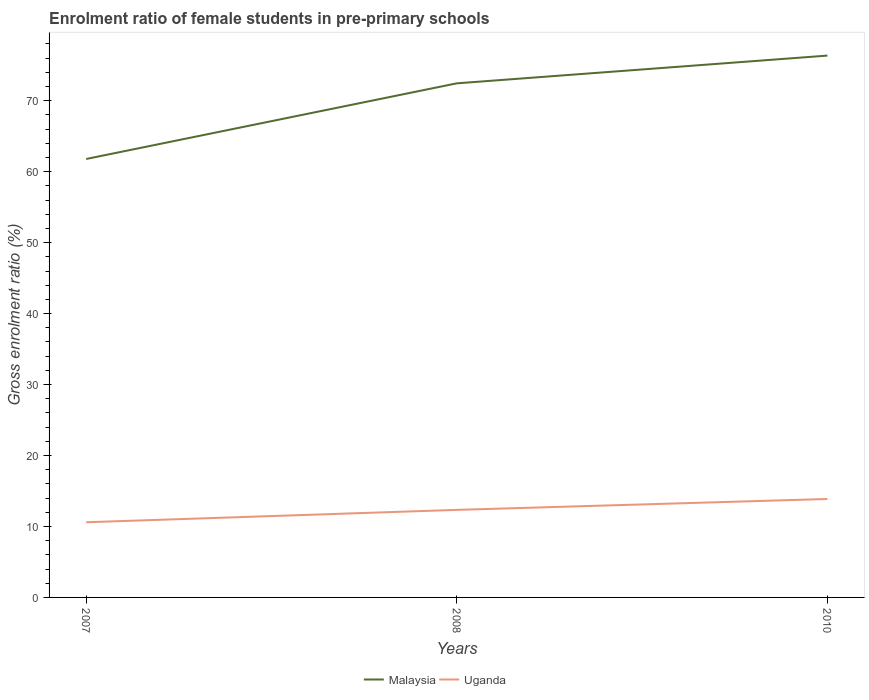Does the line corresponding to Uganda intersect with the line corresponding to Malaysia?
Your answer should be compact. No. Is the number of lines equal to the number of legend labels?
Offer a very short reply. Yes. Across all years, what is the maximum enrolment ratio of female students in pre-primary schools in Uganda?
Your answer should be compact. 10.59. What is the total enrolment ratio of female students in pre-primary schools in Uganda in the graph?
Provide a short and direct response. -1.54. What is the difference between the highest and the second highest enrolment ratio of female students in pre-primary schools in Uganda?
Provide a short and direct response. 3.28. How many lines are there?
Make the answer very short. 2. Does the graph contain grids?
Your answer should be very brief. No. How many legend labels are there?
Ensure brevity in your answer.  2. How are the legend labels stacked?
Provide a succinct answer. Horizontal. What is the title of the graph?
Keep it short and to the point. Enrolment ratio of female students in pre-primary schools. Does "Sub-Saharan Africa (developing only)" appear as one of the legend labels in the graph?
Make the answer very short. No. What is the label or title of the X-axis?
Ensure brevity in your answer.  Years. What is the Gross enrolment ratio (%) in Malaysia in 2007?
Provide a succinct answer. 61.79. What is the Gross enrolment ratio (%) of Uganda in 2007?
Make the answer very short. 10.59. What is the Gross enrolment ratio (%) in Malaysia in 2008?
Give a very brief answer. 72.45. What is the Gross enrolment ratio (%) in Uganda in 2008?
Provide a succinct answer. 12.34. What is the Gross enrolment ratio (%) in Malaysia in 2010?
Your answer should be compact. 76.36. What is the Gross enrolment ratio (%) of Uganda in 2010?
Provide a short and direct response. 13.87. Across all years, what is the maximum Gross enrolment ratio (%) in Malaysia?
Offer a very short reply. 76.36. Across all years, what is the maximum Gross enrolment ratio (%) in Uganda?
Ensure brevity in your answer.  13.87. Across all years, what is the minimum Gross enrolment ratio (%) in Malaysia?
Provide a short and direct response. 61.79. Across all years, what is the minimum Gross enrolment ratio (%) in Uganda?
Your answer should be compact. 10.59. What is the total Gross enrolment ratio (%) in Malaysia in the graph?
Provide a short and direct response. 210.6. What is the total Gross enrolment ratio (%) of Uganda in the graph?
Offer a terse response. 36.81. What is the difference between the Gross enrolment ratio (%) in Malaysia in 2007 and that in 2008?
Ensure brevity in your answer.  -10.66. What is the difference between the Gross enrolment ratio (%) of Uganda in 2007 and that in 2008?
Your answer should be compact. -1.74. What is the difference between the Gross enrolment ratio (%) of Malaysia in 2007 and that in 2010?
Ensure brevity in your answer.  -14.57. What is the difference between the Gross enrolment ratio (%) in Uganda in 2007 and that in 2010?
Your response must be concise. -3.28. What is the difference between the Gross enrolment ratio (%) of Malaysia in 2008 and that in 2010?
Your answer should be compact. -3.91. What is the difference between the Gross enrolment ratio (%) in Uganda in 2008 and that in 2010?
Provide a short and direct response. -1.54. What is the difference between the Gross enrolment ratio (%) of Malaysia in 2007 and the Gross enrolment ratio (%) of Uganda in 2008?
Give a very brief answer. 49.45. What is the difference between the Gross enrolment ratio (%) of Malaysia in 2007 and the Gross enrolment ratio (%) of Uganda in 2010?
Give a very brief answer. 47.92. What is the difference between the Gross enrolment ratio (%) in Malaysia in 2008 and the Gross enrolment ratio (%) in Uganda in 2010?
Provide a short and direct response. 58.58. What is the average Gross enrolment ratio (%) in Malaysia per year?
Ensure brevity in your answer.  70.2. What is the average Gross enrolment ratio (%) in Uganda per year?
Your response must be concise. 12.27. In the year 2007, what is the difference between the Gross enrolment ratio (%) in Malaysia and Gross enrolment ratio (%) in Uganda?
Keep it short and to the point. 51.2. In the year 2008, what is the difference between the Gross enrolment ratio (%) in Malaysia and Gross enrolment ratio (%) in Uganda?
Provide a succinct answer. 60.11. In the year 2010, what is the difference between the Gross enrolment ratio (%) in Malaysia and Gross enrolment ratio (%) in Uganda?
Give a very brief answer. 62.49. What is the ratio of the Gross enrolment ratio (%) in Malaysia in 2007 to that in 2008?
Your response must be concise. 0.85. What is the ratio of the Gross enrolment ratio (%) in Uganda in 2007 to that in 2008?
Offer a terse response. 0.86. What is the ratio of the Gross enrolment ratio (%) in Malaysia in 2007 to that in 2010?
Offer a terse response. 0.81. What is the ratio of the Gross enrolment ratio (%) of Uganda in 2007 to that in 2010?
Your response must be concise. 0.76. What is the ratio of the Gross enrolment ratio (%) of Malaysia in 2008 to that in 2010?
Your answer should be compact. 0.95. What is the ratio of the Gross enrolment ratio (%) in Uganda in 2008 to that in 2010?
Provide a succinct answer. 0.89. What is the difference between the highest and the second highest Gross enrolment ratio (%) in Malaysia?
Ensure brevity in your answer.  3.91. What is the difference between the highest and the second highest Gross enrolment ratio (%) of Uganda?
Keep it short and to the point. 1.54. What is the difference between the highest and the lowest Gross enrolment ratio (%) of Malaysia?
Ensure brevity in your answer.  14.57. What is the difference between the highest and the lowest Gross enrolment ratio (%) in Uganda?
Keep it short and to the point. 3.28. 